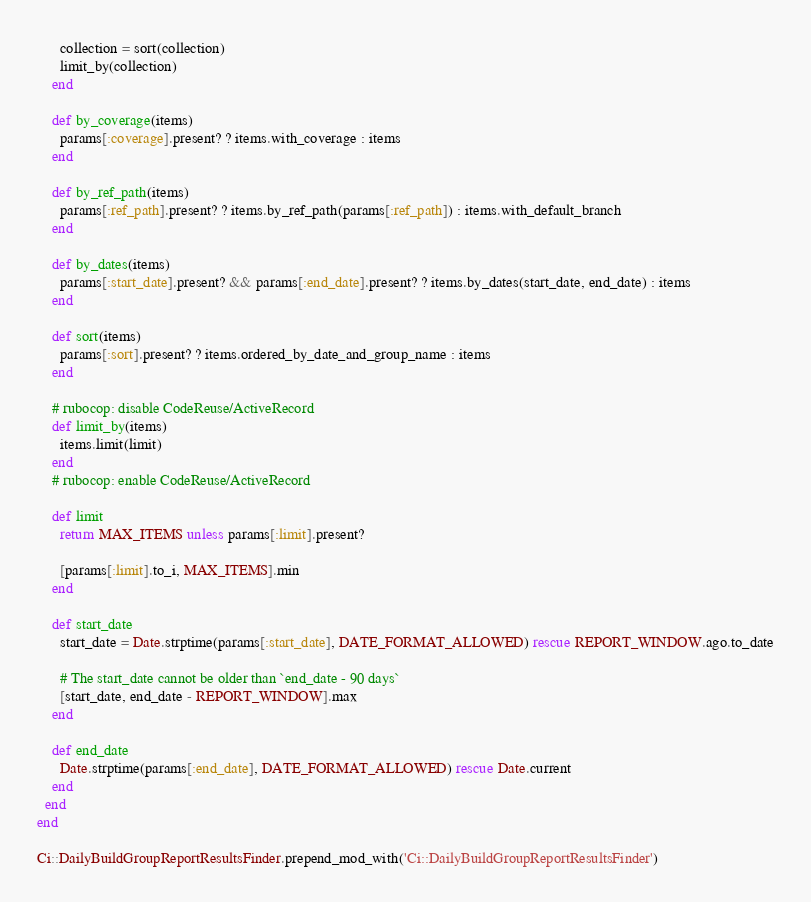<code> <loc_0><loc_0><loc_500><loc_500><_Ruby_>      collection = sort(collection)
      limit_by(collection)
    end

    def by_coverage(items)
      params[:coverage].present? ? items.with_coverage : items
    end

    def by_ref_path(items)
      params[:ref_path].present? ? items.by_ref_path(params[:ref_path]) : items.with_default_branch
    end

    def by_dates(items)
      params[:start_date].present? && params[:end_date].present? ? items.by_dates(start_date, end_date) : items
    end

    def sort(items)
      params[:sort].present? ? items.ordered_by_date_and_group_name : items
    end

    # rubocop: disable CodeReuse/ActiveRecord
    def limit_by(items)
      items.limit(limit)
    end
    # rubocop: enable CodeReuse/ActiveRecord

    def limit
      return MAX_ITEMS unless params[:limit].present?

      [params[:limit].to_i, MAX_ITEMS].min
    end

    def start_date
      start_date = Date.strptime(params[:start_date], DATE_FORMAT_ALLOWED) rescue REPORT_WINDOW.ago.to_date

      # The start_date cannot be older than `end_date - 90 days`
      [start_date, end_date - REPORT_WINDOW].max
    end

    def end_date
      Date.strptime(params[:end_date], DATE_FORMAT_ALLOWED) rescue Date.current
    end
  end
end

Ci::DailyBuildGroupReportResultsFinder.prepend_mod_with('Ci::DailyBuildGroupReportResultsFinder')
</code> 